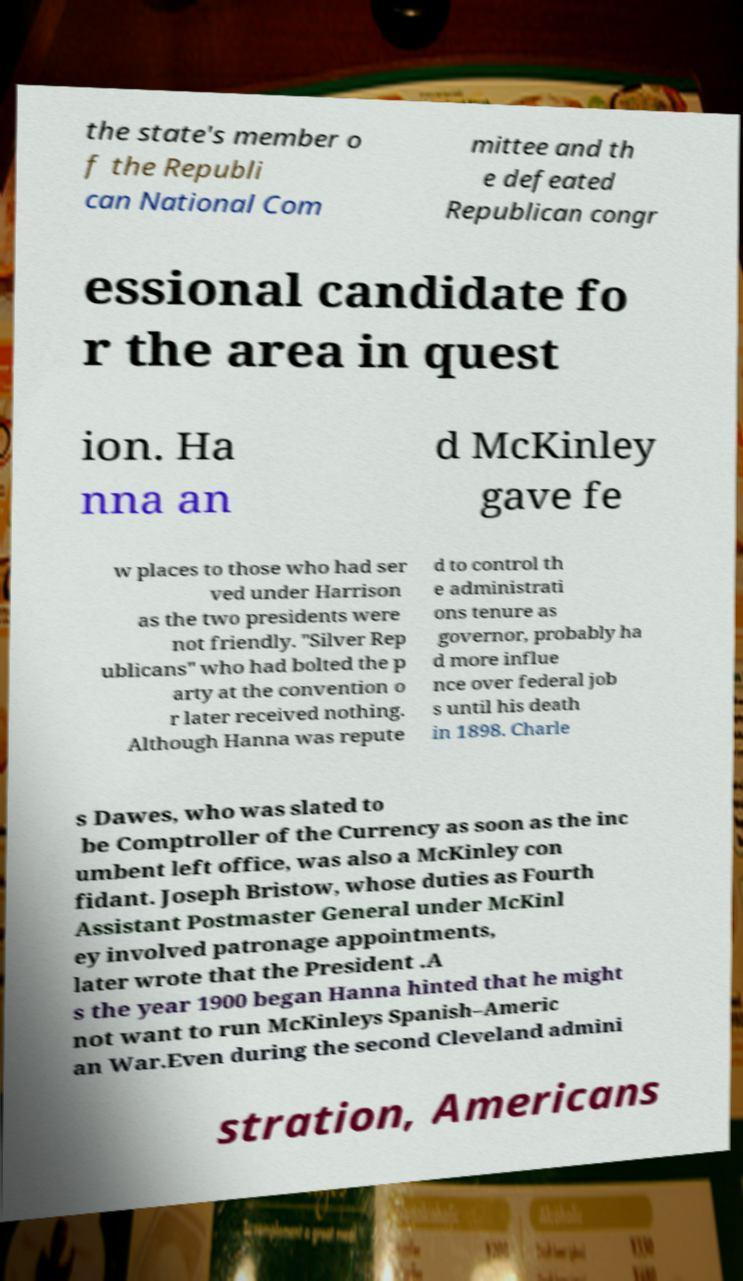Can you accurately transcribe the text from the provided image for me? the state's member o f the Republi can National Com mittee and th e defeated Republican congr essional candidate fo r the area in quest ion. Ha nna an d McKinley gave fe w places to those who had ser ved under Harrison as the two presidents were not friendly. "Silver Rep ublicans" who had bolted the p arty at the convention o r later received nothing. Although Hanna was repute d to control th e administrati ons tenure as governor, probably ha d more influe nce over federal job s until his death in 1898. Charle s Dawes, who was slated to be Comptroller of the Currency as soon as the inc umbent left office, was also a McKinley con fidant. Joseph Bristow, whose duties as Fourth Assistant Postmaster General under McKinl ey involved patronage appointments, later wrote that the President .A s the year 1900 began Hanna hinted that he might not want to run McKinleys Spanish–Americ an War.Even during the second Cleveland admini stration, Americans 